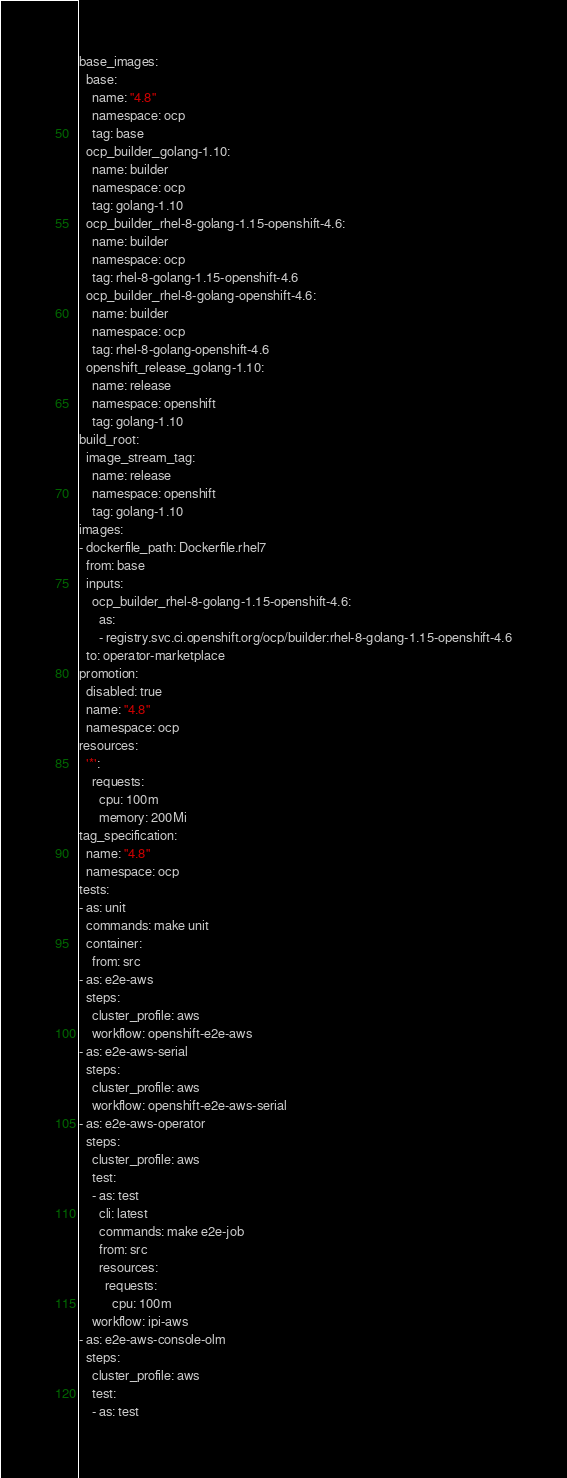Convert code to text. <code><loc_0><loc_0><loc_500><loc_500><_YAML_>base_images:
  base:
    name: "4.8"
    namespace: ocp
    tag: base
  ocp_builder_golang-1.10:
    name: builder
    namespace: ocp
    tag: golang-1.10
  ocp_builder_rhel-8-golang-1.15-openshift-4.6:
    name: builder
    namespace: ocp
    tag: rhel-8-golang-1.15-openshift-4.6
  ocp_builder_rhel-8-golang-openshift-4.6:
    name: builder
    namespace: ocp
    tag: rhel-8-golang-openshift-4.6
  openshift_release_golang-1.10:
    name: release
    namespace: openshift
    tag: golang-1.10
build_root:
  image_stream_tag:
    name: release
    namespace: openshift
    tag: golang-1.10
images:
- dockerfile_path: Dockerfile.rhel7
  from: base
  inputs:
    ocp_builder_rhel-8-golang-1.15-openshift-4.6:
      as:
      - registry.svc.ci.openshift.org/ocp/builder:rhel-8-golang-1.15-openshift-4.6
  to: operator-marketplace
promotion:
  disabled: true
  name: "4.8"
  namespace: ocp
resources:
  '*':
    requests:
      cpu: 100m
      memory: 200Mi
tag_specification:
  name: "4.8"
  namespace: ocp
tests:
- as: unit
  commands: make unit
  container:
    from: src
- as: e2e-aws
  steps:
    cluster_profile: aws
    workflow: openshift-e2e-aws
- as: e2e-aws-serial
  steps:
    cluster_profile: aws
    workflow: openshift-e2e-aws-serial
- as: e2e-aws-operator
  steps:
    cluster_profile: aws
    test:
    - as: test
      cli: latest
      commands: make e2e-job
      from: src
      resources:
        requests:
          cpu: 100m
    workflow: ipi-aws
- as: e2e-aws-console-olm
  steps:
    cluster_profile: aws
    test:
    - as: test</code> 